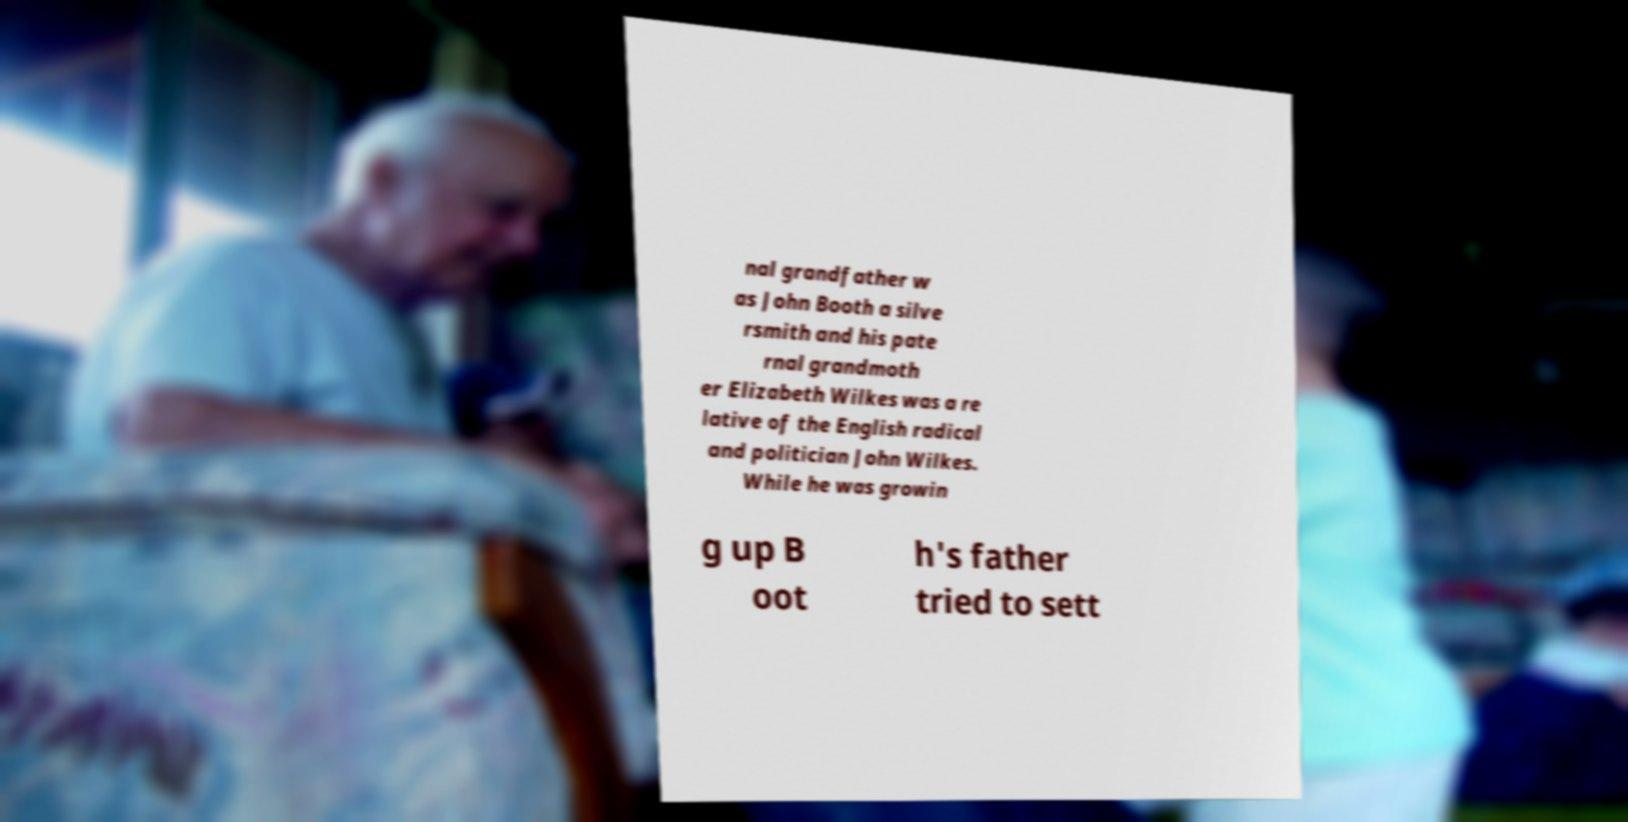For documentation purposes, I need the text within this image transcribed. Could you provide that? nal grandfather w as John Booth a silve rsmith and his pate rnal grandmoth er Elizabeth Wilkes was a re lative of the English radical and politician John Wilkes. While he was growin g up B oot h's father tried to sett 